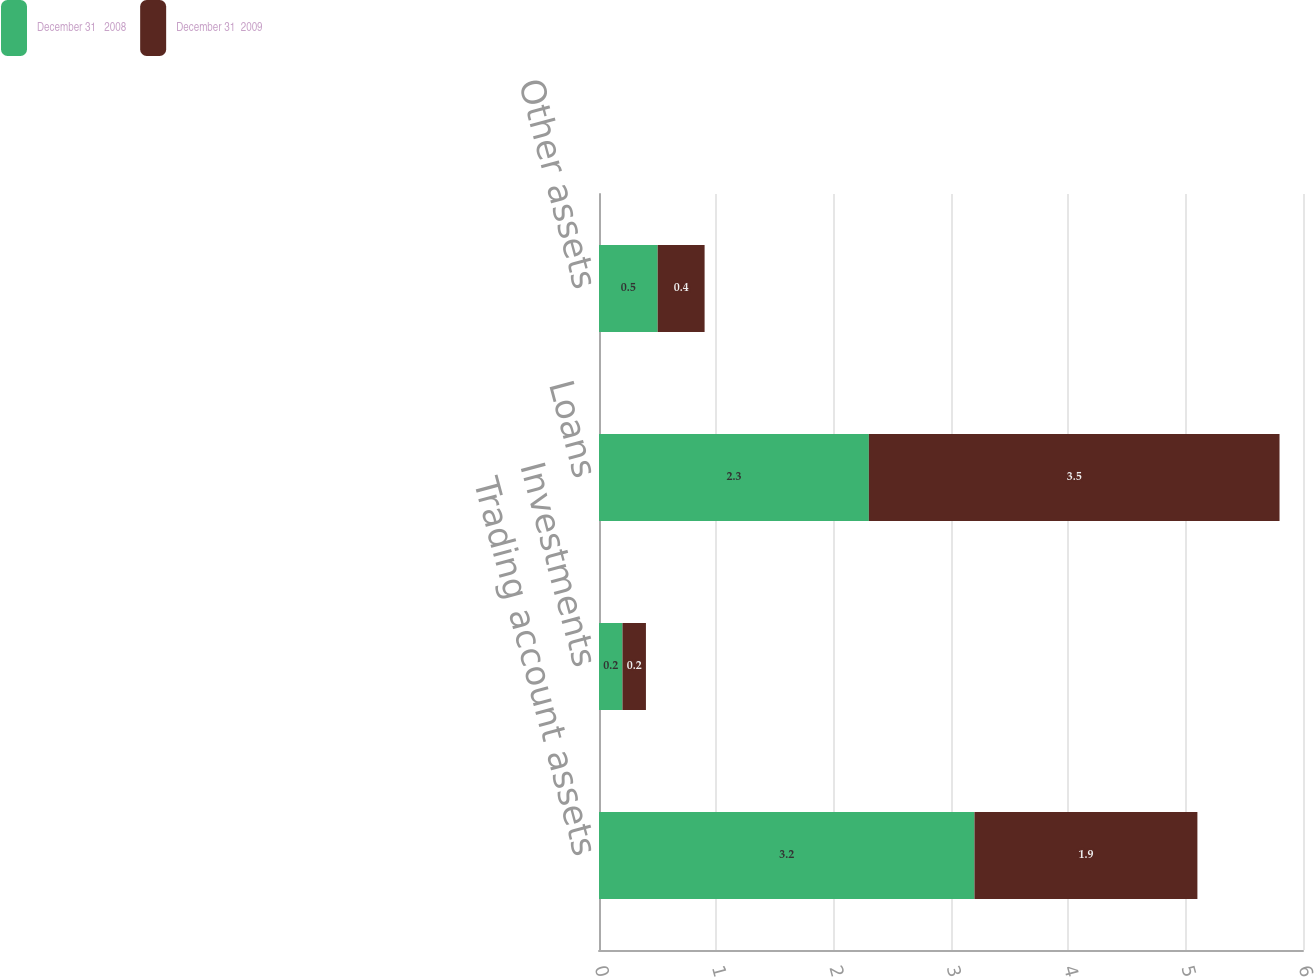Convert chart. <chart><loc_0><loc_0><loc_500><loc_500><stacked_bar_chart><ecel><fcel>Trading account assets<fcel>Investments<fcel>Loans<fcel>Other assets<nl><fcel>December 31   2008<fcel>3.2<fcel>0.2<fcel>2.3<fcel>0.5<nl><fcel>December 31  2009<fcel>1.9<fcel>0.2<fcel>3.5<fcel>0.4<nl></chart> 